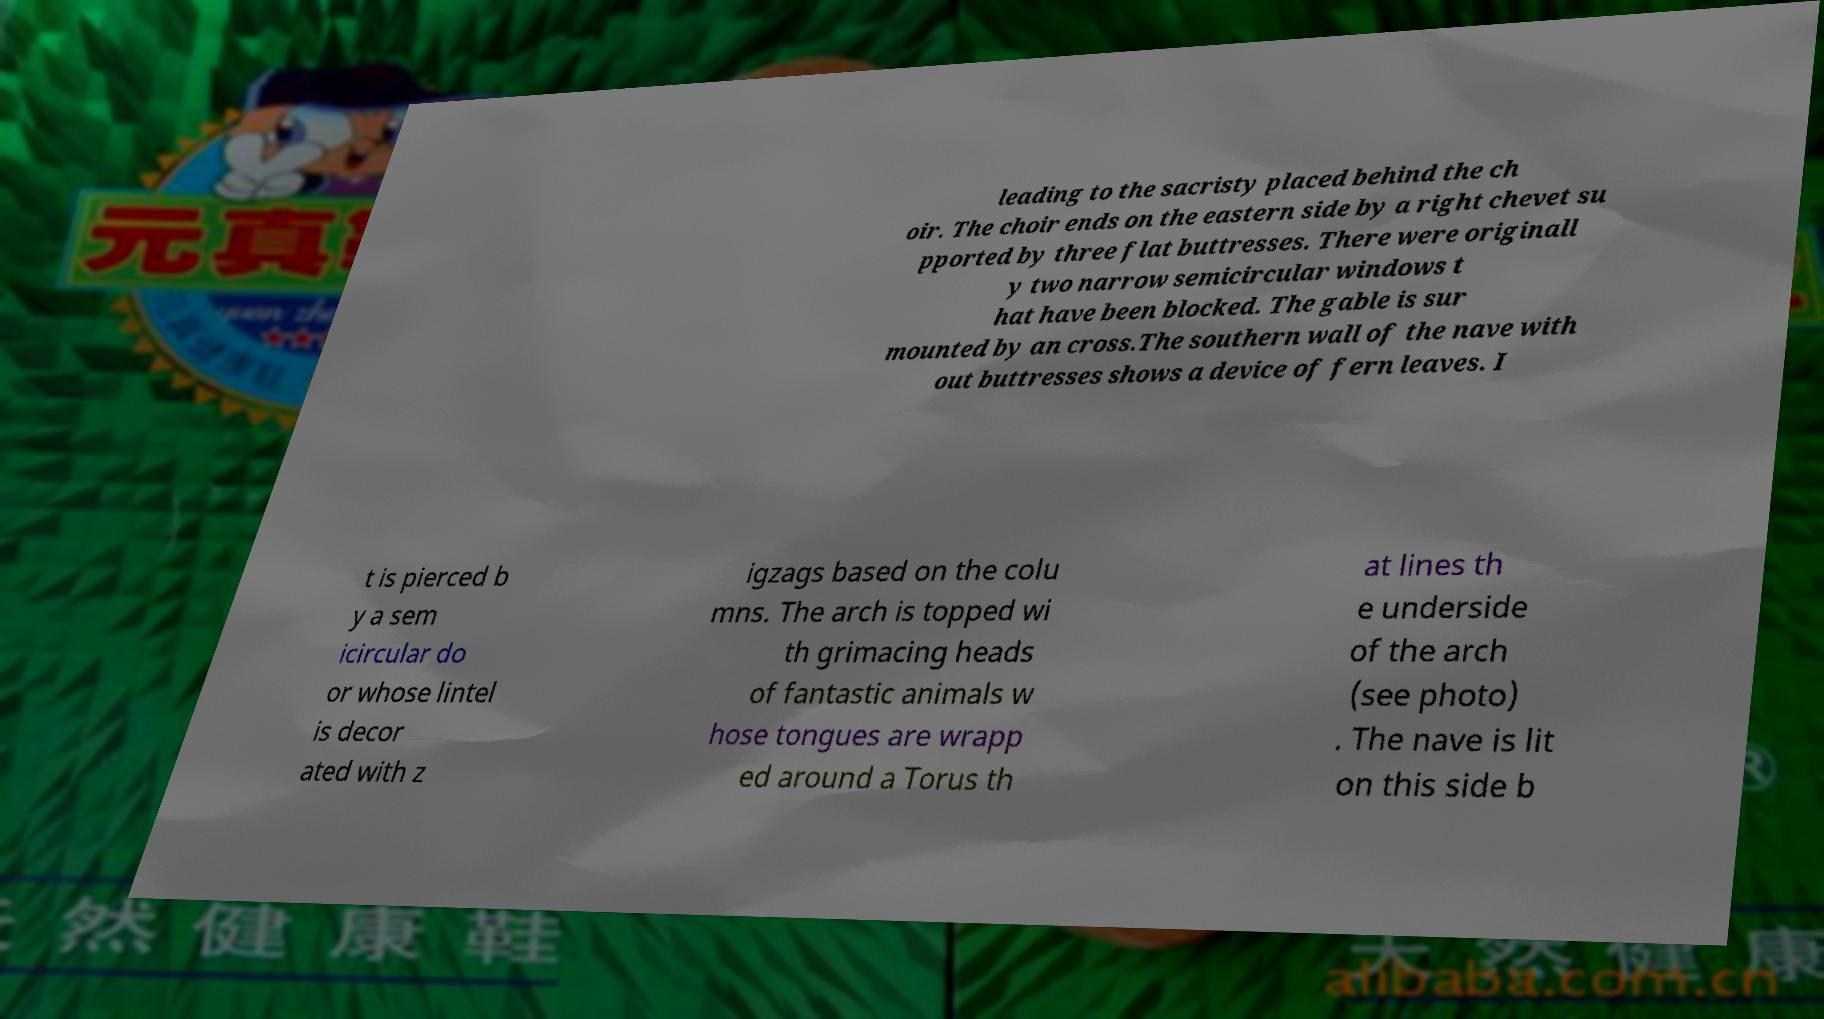There's text embedded in this image that I need extracted. Can you transcribe it verbatim? leading to the sacristy placed behind the ch oir. The choir ends on the eastern side by a right chevet su pported by three flat buttresses. There were originall y two narrow semicircular windows t hat have been blocked. The gable is sur mounted by an cross.The southern wall of the nave with out buttresses shows a device of fern leaves. I t is pierced b y a sem icircular do or whose lintel is decor ated with z igzags based on the colu mns. The arch is topped wi th grimacing heads of fantastic animals w hose tongues are wrapp ed around a Torus th at lines th e underside of the arch (see photo) . The nave is lit on this side b 